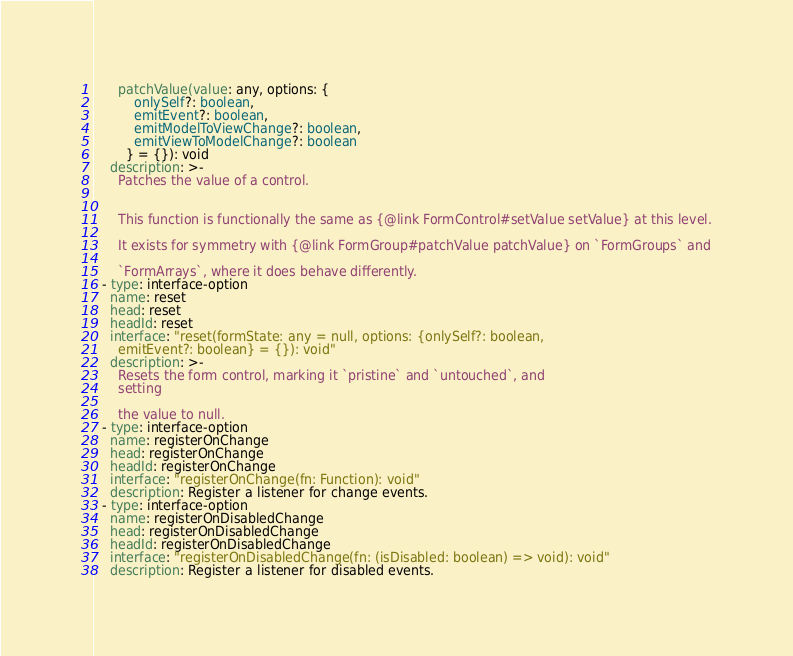<code> <loc_0><loc_0><loc_500><loc_500><_YAML_>      patchValue(value: any, options: {
          onlySelf?: boolean,
          emitEvent?: boolean,
          emitModelToViewChange?: boolean,
          emitViewToModelChange?: boolean
        } = {}): void
    description: >-
      Patches the value of a control.


      This function is functionally the same as {@link FormControl#setValue setValue} at this level.

      It exists for symmetry with {@link FormGroup#patchValue patchValue} on `FormGroups` and

      `FormArrays`, where it does behave differently.
  - type: interface-option
    name: reset
    head: reset
    headId: reset
    interface: "reset(formState: any = null, options: {onlySelf?: boolean,
      emitEvent?: boolean} = {}): void"
    description: >-
      Resets the form control, marking it `pristine` and `untouched`, and
      setting

      the value to null.
  - type: interface-option
    name: registerOnChange
    head: registerOnChange
    headId: registerOnChange
    interface: "registerOnChange(fn: Function): void"
    description: Register a listener for change events.
  - type: interface-option
    name: registerOnDisabledChange
    head: registerOnDisabledChange
    headId: registerOnDisabledChange
    interface: "registerOnDisabledChange(fn: (isDisabled: boolean) => void): void"
    description: Register a listener for disabled events.
</code> 